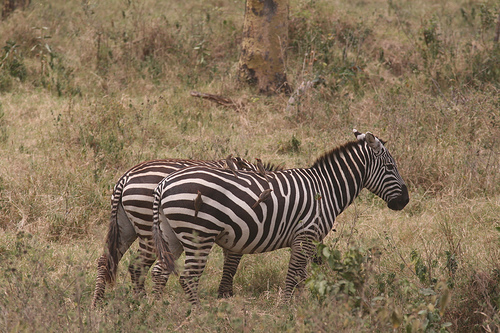<image>Which front foot does the rear zebra have forward? It is ambiguous which front foot the rear zebra has forward. Which front foot does the rear zebra have forward? It is unknown which front foot does the rear zebra have forward. 